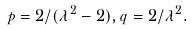Convert formula to latex. <formula><loc_0><loc_0><loc_500><loc_500>p = 2 / ( \lambda ^ { 2 } - 2 ) , q = 2 / \lambda ^ { 2 } .</formula> 